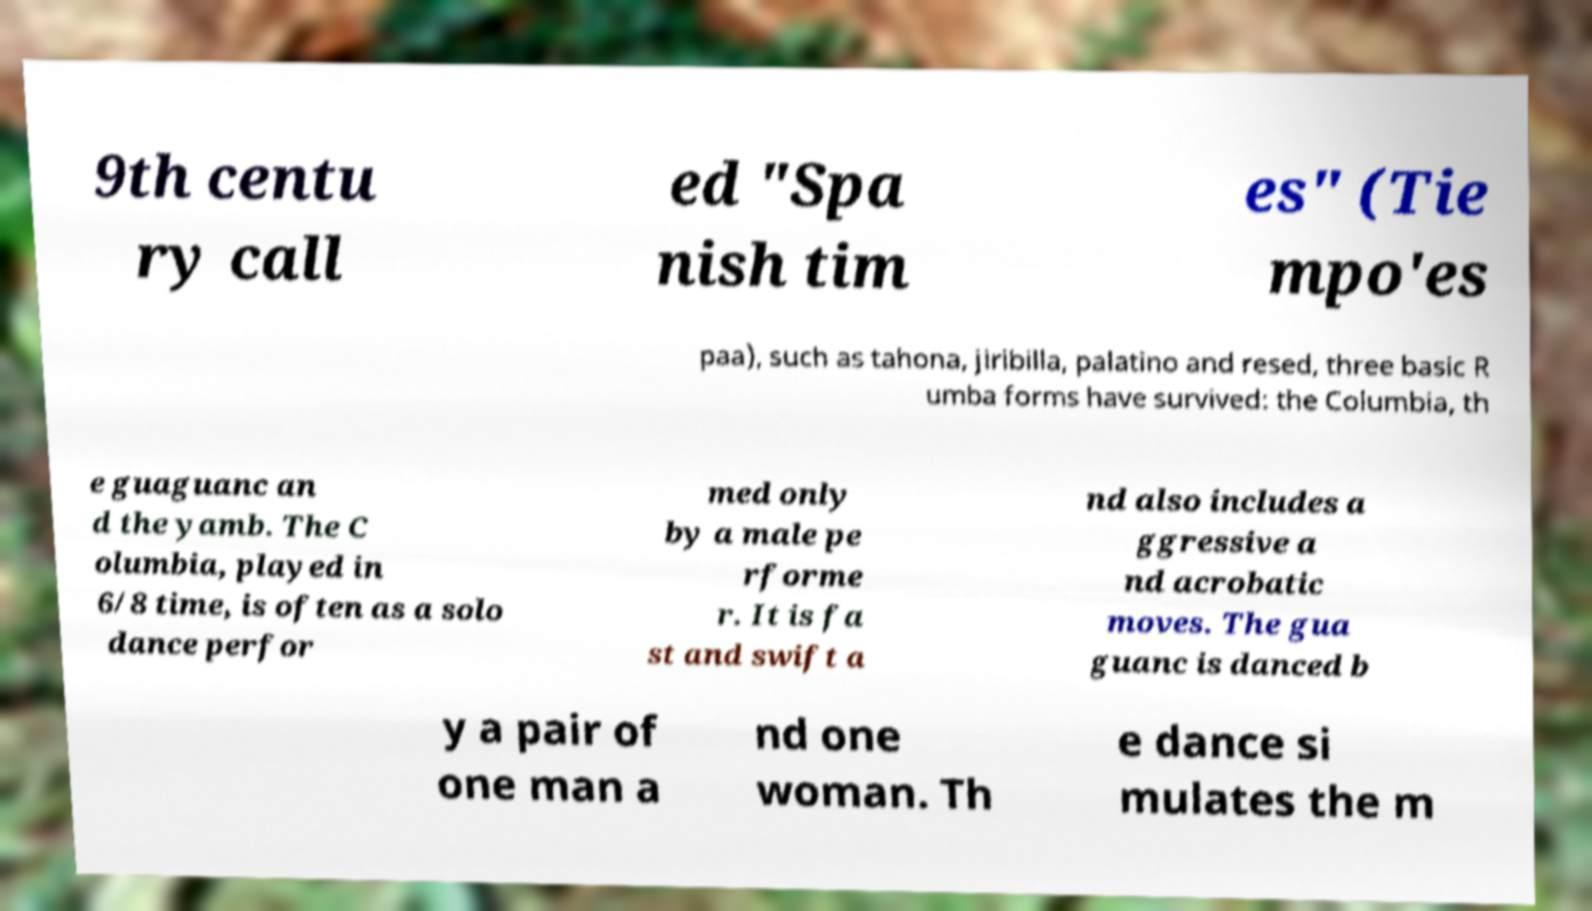Please read and relay the text visible in this image. What does it say? 9th centu ry call ed "Spa nish tim es" (Tie mpo'es paa), such as tahona, jiribilla, palatino and resed, three basic R umba forms have survived: the Columbia, th e guaguanc an d the yamb. The C olumbia, played in 6/8 time, is often as a solo dance perfor med only by a male pe rforme r. It is fa st and swift a nd also includes a ggressive a nd acrobatic moves. The gua guanc is danced b y a pair of one man a nd one woman. Th e dance si mulates the m 